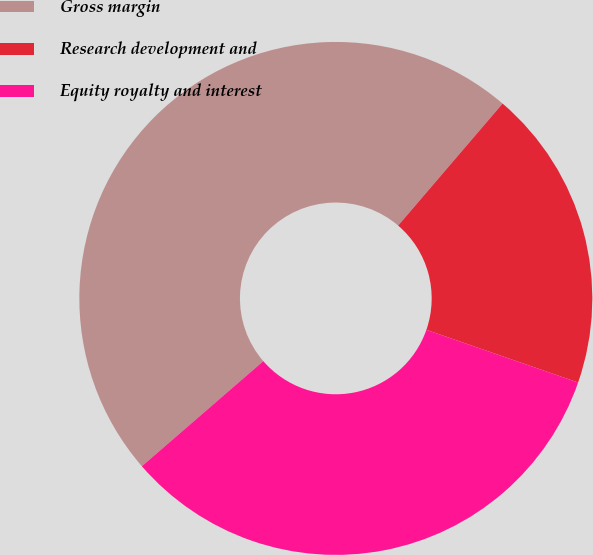<chart> <loc_0><loc_0><loc_500><loc_500><pie_chart><fcel>Gross margin<fcel>Research development and<fcel>Equity royalty and interest<nl><fcel>47.62%<fcel>19.05%<fcel>33.33%<nl></chart> 